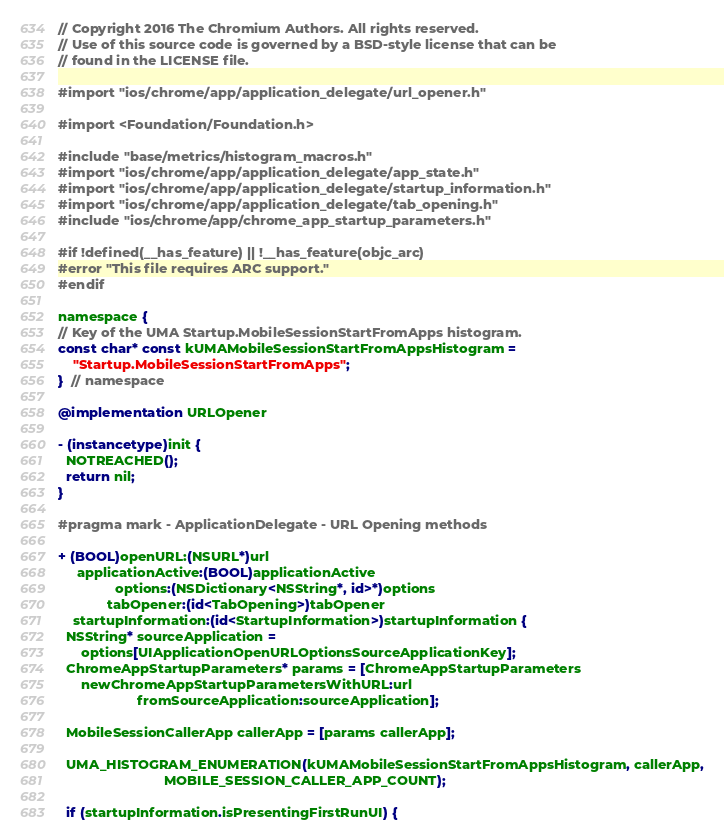<code> <loc_0><loc_0><loc_500><loc_500><_ObjectiveC_>// Copyright 2016 The Chromium Authors. All rights reserved.
// Use of this source code is governed by a BSD-style license that can be
// found in the LICENSE file.

#import "ios/chrome/app/application_delegate/url_opener.h"

#import <Foundation/Foundation.h>

#include "base/metrics/histogram_macros.h"
#import "ios/chrome/app/application_delegate/app_state.h"
#import "ios/chrome/app/application_delegate/startup_information.h"
#import "ios/chrome/app/application_delegate/tab_opening.h"
#include "ios/chrome/app/chrome_app_startup_parameters.h"

#if !defined(__has_feature) || !__has_feature(objc_arc)
#error "This file requires ARC support."
#endif

namespace {
// Key of the UMA Startup.MobileSessionStartFromApps histogram.
const char* const kUMAMobileSessionStartFromAppsHistogram =
    "Startup.MobileSessionStartFromApps";
}  // namespace

@implementation URLOpener

- (instancetype)init {
  NOTREACHED();
  return nil;
}

#pragma mark - ApplicationDelegate - URL Opening methods

+ (BOOL)openURL:(NSURL*)url
     applicationActive:(BOOL)applicationActive
               options:(NSDictionary<NSString*, id>*)options
             tabOpener:(id<TabOpening>)tabOpener
    startupInformation:(id<StartupInformation>)startupInformation {
  NSString* sourceApplication =
      options[UIApplicationOpenURLOptionsSourceApplicationKey];
  ChromeAppStartupParameters* params = [ChromeAppStartupParameters
      newChromeAppStartupParametersWithURL:url
                     fromSourceApplication:sourceApplication];

  MobileSessionCallerApp callerApp = [params callerApp];

  UMA_HISTOGRAM_ENUMERATION(kUMAMobileSessionStartFromAppsHistogram, callerApp,
                            MOBILE_SESSION_CALLER_APP_COUNT);

  if (startupInformation.isPresentingFirstRunUI) {</code> 